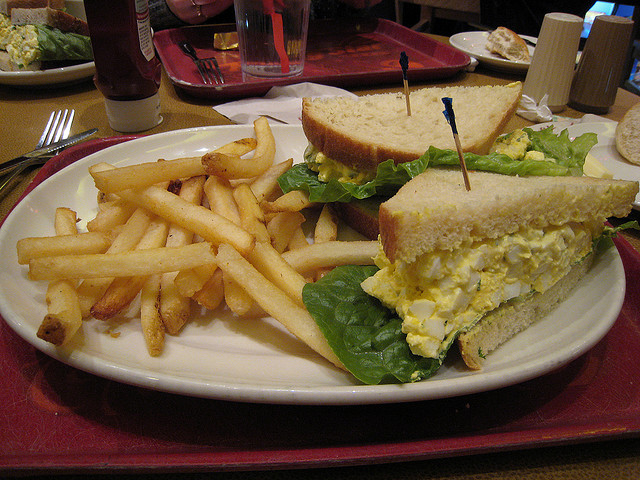<image>What color are the napkins? I am not sure what color the napkins are. They could be white, yellow or red. How can you tell the French Fries are being shared between people? It is ambiguous whether the French Fries are being shared between people. What is the text etched in the edge of the plate? There is no text etched in the edge of the plate. Is the food laying on what color napkin? It is ambiguous what color the napkin is, as it can be seen either white or none. Where are the sausages? There are no sausages in the image. What color are the napkins? The napkins in the image are white. Is the food laying on what color napkin? There is no napkin visible in the image. What is the text etched in the edge of the plate? There is no text etched in the edge of the plate. How can you tell the French Fries are being shared between people? I am not sure how you can tell the French Fries are being shared between people. It can be because there are a lot of fries or a large portion. Where are the sausages? There are no sausages in the image. 